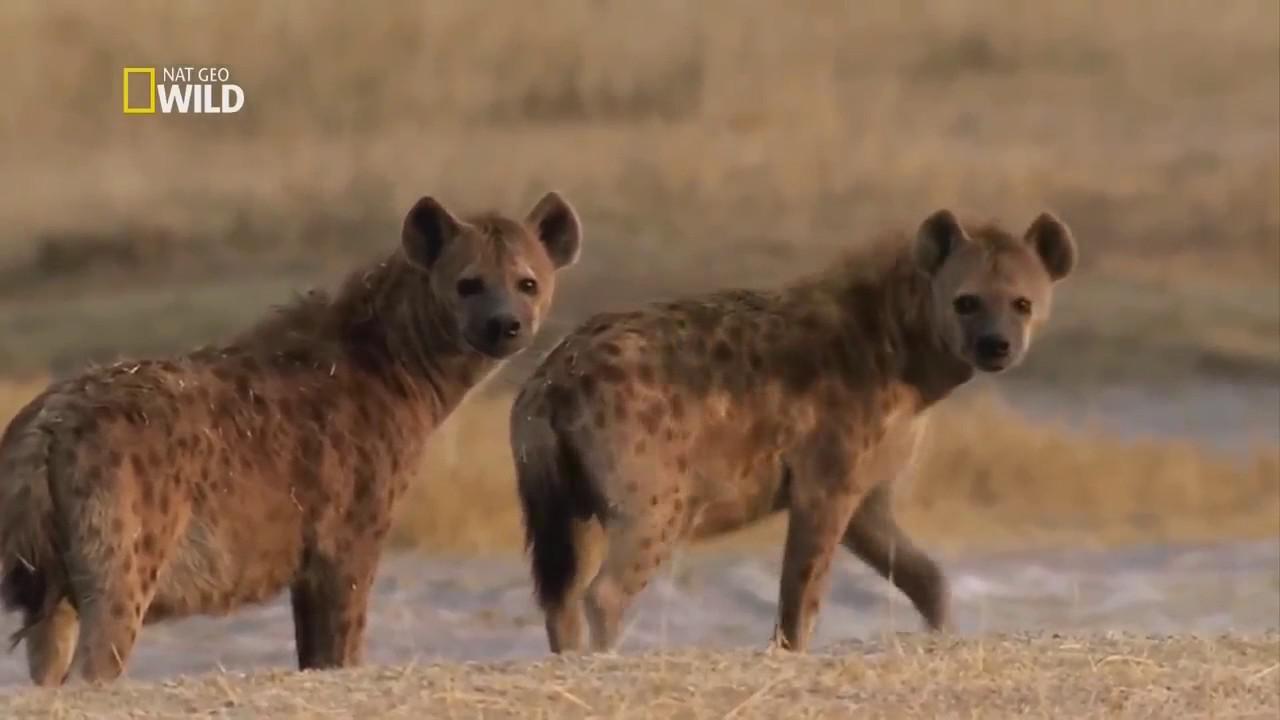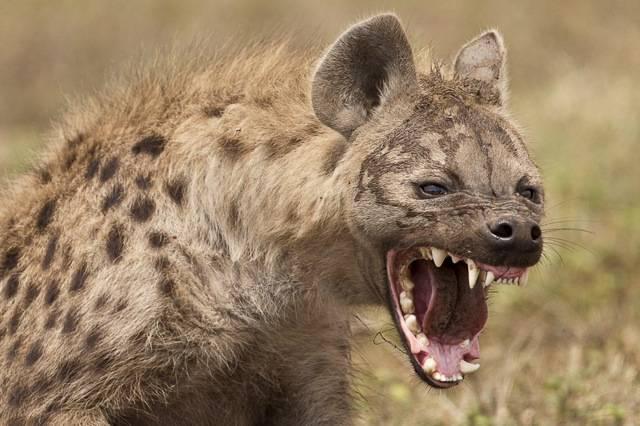The first image is the image on the left, the second image is the image on the right. Evaluate the accuracy of this statement regarding the images: "Exactly one hyena's teeth are visible.". Is it true? Answer yes or no. Yes. The first image is the image on the left, the second image is the image on the right. Examine the images to the left and right. Is the description "Exactly one hyena is baring its fangs with wide-opened mouth, and no image shows hyenas posed face-to-face." accurate? Answer yes or no. Yes. 